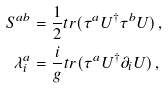<formula> <loc_0><loc_0><loc_500><loc_500>S ^ { a b } & = \frac { 1 } { 2 } t r ( \tau ^ { a } U ^ { \dag } \tau ^ { b } U ) \, , \\ \lambda ^ { a } _ { i } & = \frac { i } { g } t r ( \tau ^ { a } U ^ { \dag } \partial _ { i } U ) \, ,</formula> 